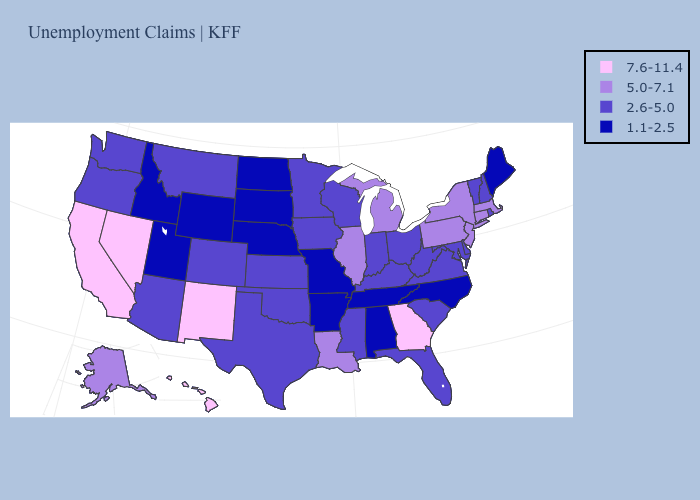What is the value of Maryland?
Answer briefly. 2.6-5.0. What is the highest value in states that border Colorado?
Be succinct. 7.6-11.4. What is the value of Wyoming?
Keep it brief. 1.1-2.5. Name the states that have a value in the range 2.6-5.0?
Write a very short answer. Arizona, Colorado, Delaware, Florida, Indiana, Iowa, Kansas, Kentucky, Maryland, Minnesota, Mississippi, Montana, New Hampshire, Ohio, Oklahoma, Oregon, Rhode Island, South Carolina, Texas, Vermont, Virginia, Washington, West Virginia, Wisconsin. Among the states that border Colorado , does Wyoming have the lowest value?
Concise answer only. Yes. What is the value of New Mexico?
Keep it brief. 7.6-11.4. Does Kentucky have a higher value than Tennessee?
Give a very brief answer. Yes. Name the states that have a value in the range 2.6-5.0?
Be succinct. Arizona, Colorado, Delaware, Florida, Indiana, Iowa, Kansas, Kentucky, Maryland, Minnesota, Mississippi, Montana, New Hampshire, Ohio, Oklahoma, Oregon, Rhode Island, South Carolina, Texas, Vermont, Virginia, Washington, West Virginia, Wisconsin. Name the states that have a value in the range 2.6-5.0?
Quick response, please. Arizona, Colorado, Delaware, Florida, Indiana, Iowa, Kansas, Kentucky, Maryland, Minnesota, Mississippi, Montana, New Hampshire, Ohio, Oklahoma, Oregon, Rhode Island, South Carolina, Texas, Vermont, Virginia, Washington, West Virginia, Wisconsin. Does Michigan have a higher value than Georgia?
Give a very brief answer. No. What is the lowest value in states that border South Dakota?
Short answer required. 1.1-2.5. What is the lowest value in the South?
Concise answer only. 1.1-2.5. What is the highest value in states that border Pennsylvania?
Be succinct. 5.0-7.1. What is the value of New Jersey?
Concise answer only. 5.0-7.1. Name the states that have a value in the range 2.6-5.0?
Concise answer only. Arizona, Colorado, Delaware, Florida, Indiana, Iowa, Kansas, Kentucky, Maryland, Minnesota, Mississippi, Montana, New Hampshire, Ohio, Oklahoma, Oregon, Rhode Island, South Carolina, Texas, Vermont, Virginia, Washington, West Virginia, Wisconsin. 